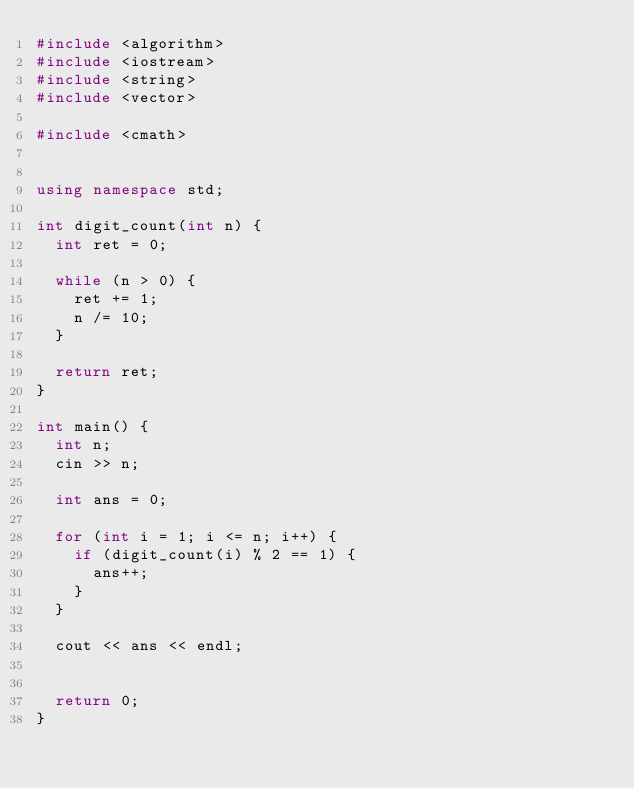Convert code to text. <code><loc_0><loc_0><loc_500><loc_500><_C++_>#include <algorithm>
#include <iostream>
#include <string>
#include <vector>

#include <cmath>


using namespace std;

int digit_count(int n) {
  int ret = 0;

  while (n > 0) {
    ret += 1;
    n /= 10;
  }

  return ret;
}

int main() {
  int n;
  cin >> n;

  int ans = 0;

  for (int i = 1; i <= n; i++) {
    if (digit_count(i) % 2 == 1) {
      ans++;
    }
  }

  cout << ans << endl;


  return 0;
}
</code> 